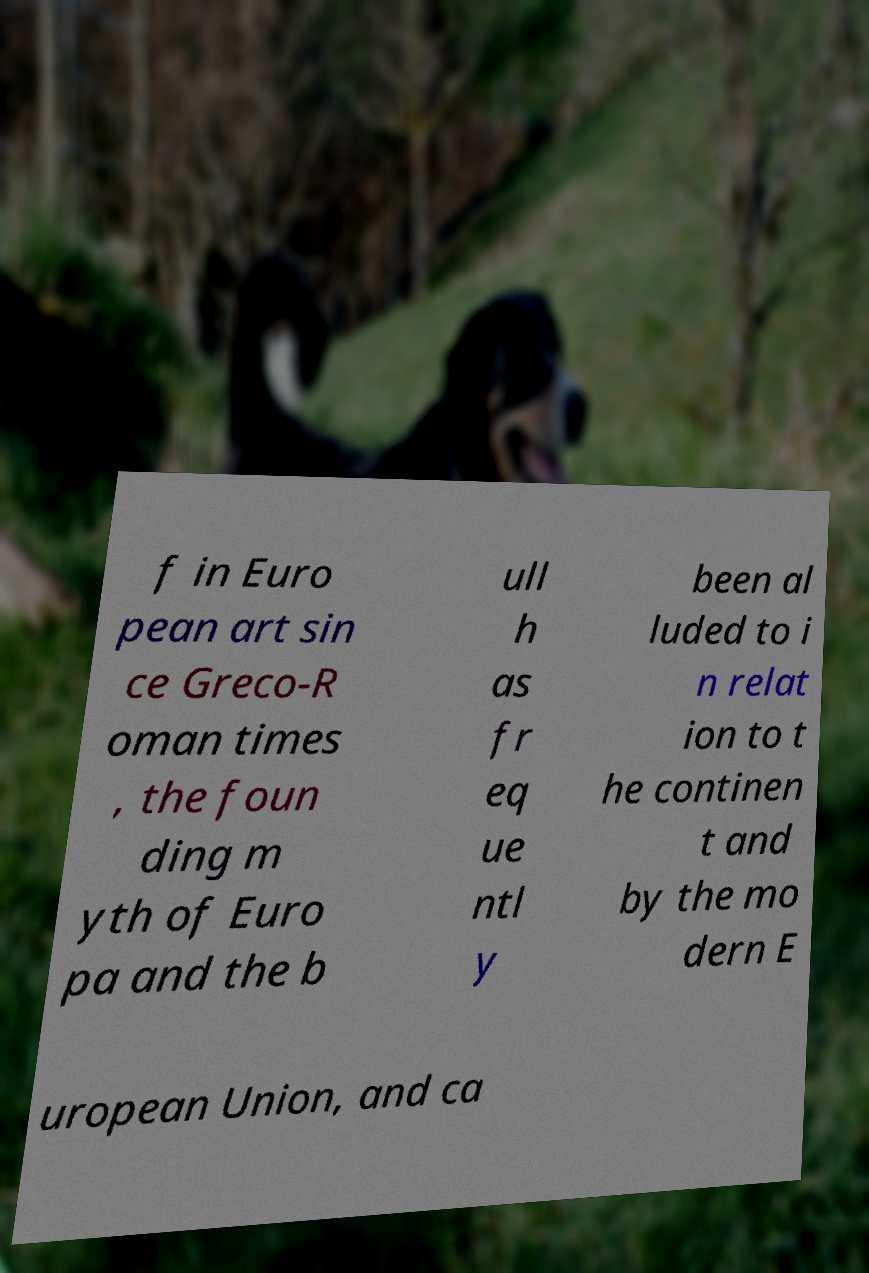Can you accurately transcribe the text from the provided image for me? f in Euro pean art sin ce Greco-R oman times , the foun ding m yth of Euro pa and the b ull h as fr eq ue ntl y been al luded to i n relat ion to t he continen t and by the mo dern E uropean Union, and ca 